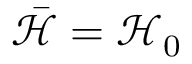<formula> <loc_0><loc_0><loc_500><loc_500>\bar { \mathcal { H } } = \mathcal { H } _ { 0 }</formula> 